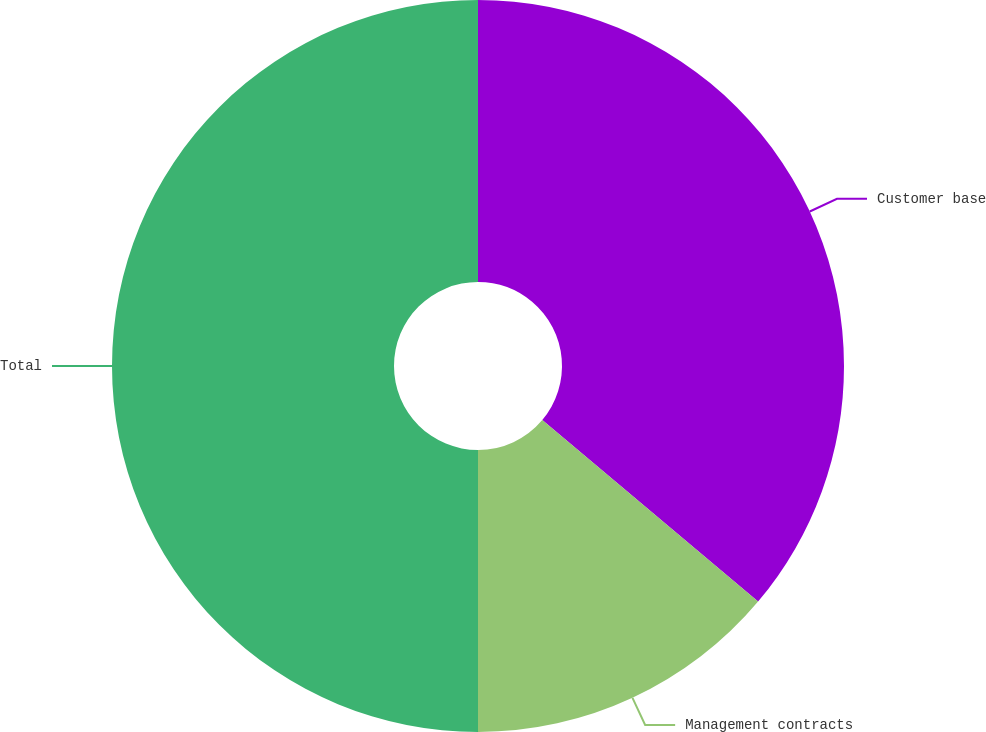Convert chart. <chart><loc_0><loc_0><loc_500><loc_500><pie_chart><fcel>Customer base<fcel>Management contracts<fcel>Total<nl><fcel>36.13%<fcel>13.87%<fcel>50.0%<nl></chart> 